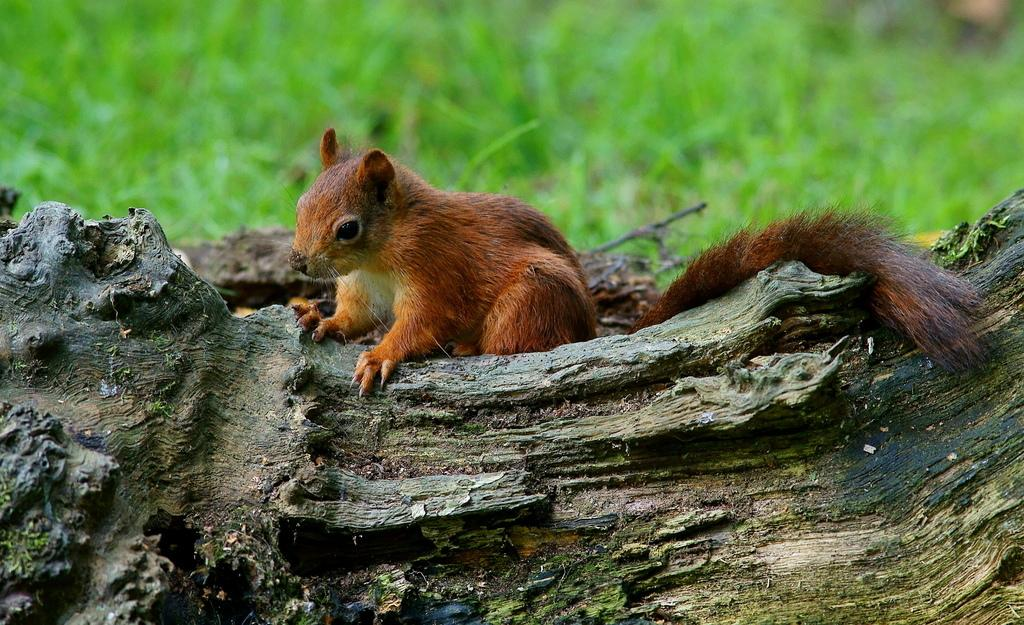What type of animal is in the image? There is a brown squirrel in the image. Where is the squirrel located? The squirrel is standing on a tree trunk. What can be seen in the background of the image? The background of the image is greenery. Where is the throne located in the image? There is no throne present in the image. How many rings does the squirrel have on its tail? The squirrel does not have any rings on its tail in the image. 